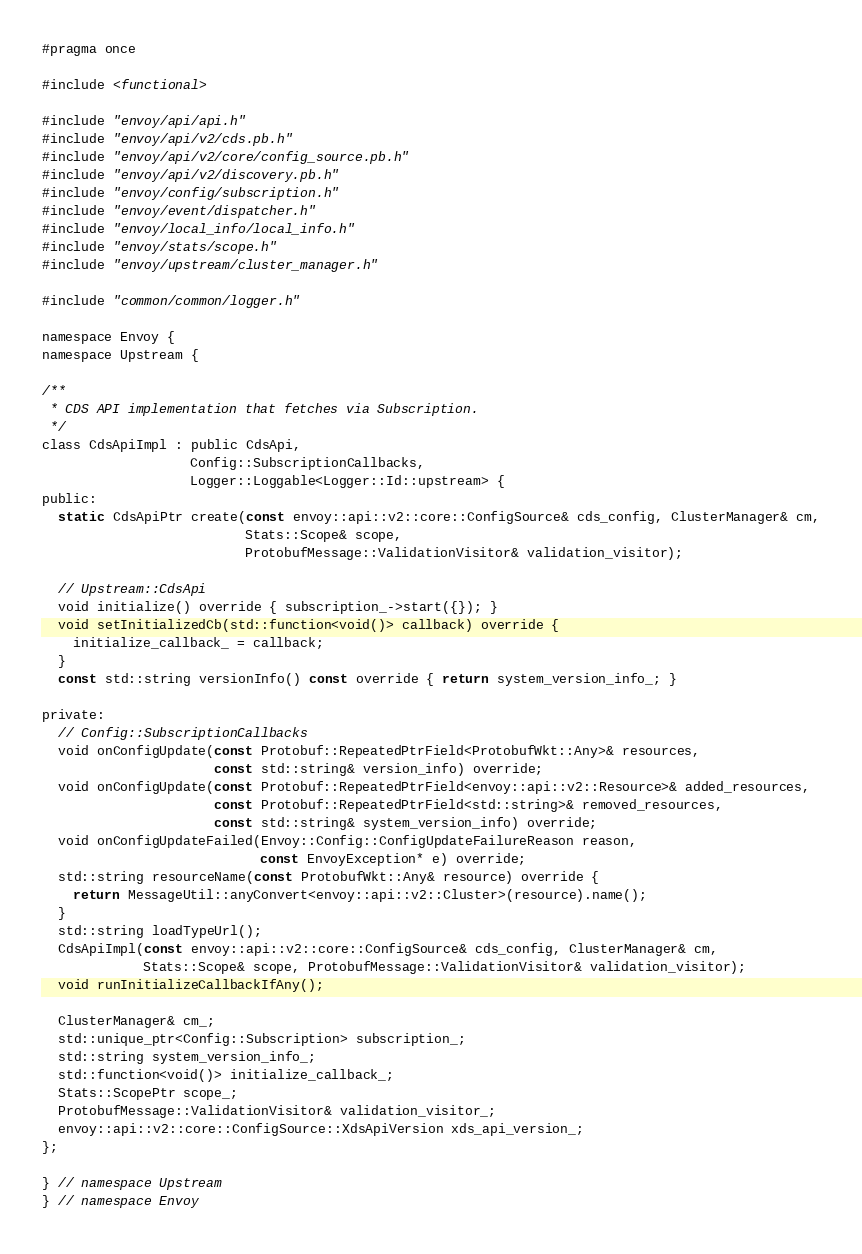Convert code to text. <code><loc_0><loc_0><loc_500><loc_500><_C_>#pragma once

#include <functional>

#include "envoy/api/api.h"
#include "envoy/api/v2/cds.pb.h"
#include "envoy/api/v2/core/config_source.pb.h"
#include "envoy/api/v2/discovery.pb.h"
#include "envoy/config/subscription.h"
#include "envoy/event/dispatcher.h"
#include "envoy/local_info/local_info.h"
#include "envoy/stats/scope.h"
#include "envoy/upstream/cluster_manager.h"

#include "common/common/logger.h"

namespace Envoy {
namespace Upstream {

/**
 * CDS API implementation that fetches via Subscription.
 */
class CdsApiImpl : public CdsApi,
                   Config::SubscriptionCallbacks,
                   Logger::Loggable<Logger::Id::upstream> {
public:
  static CdsApiPtr create(const envoy::api::v2::core::ConfigSource& cds_config, ClusterManager& cm,
                          Stats::Scope& scope,
                          ProtobufMessage::ValidationVisitor& validation_visitor);

  // Upstream::CdsApi
  void initialize() override { subscription_->start({}); }
  void setInitializedCb(std::function<void()> callback) override {
    initialize_callback_ = callback;
  }
  const std::string versionInfo() const override { return system_version_info_; }

private:
  // Config::SubscriptionCallbacks
  void onConfigUpdate(const Protobuf::RepeatedPtrField<ProtobufWkt::Any>& resources,
                      const std::string& version_info) override;
  void onConfigUpdate(const Protobuf::RepeatedPtrField<envoy::api::v2::Resource>& added_resources,
                      const Protobuf::RepeatedPtrField<std::string>& removed_resources,
                      const std::string& system_version_info) override;
  void onConfigUpdateFailed(Envoy::Config::ConfigUpdateFailureReason reason,
                            const EnvoyException* e) override;
  std::string resourceName(const ProtobufWkt::Any& resource) override {
    return MessageUtil::anyConvert<envoy::api::v2::Cluster>(resource).name();
  }
  std::string loadTypeUrl();
  CdsApiImpl(const envoy::api::v2::core::ConfigSource& cds_config, ClusterManager& cm,
             Stats::Scope& scope, ProtobufMessage::ValidationVisitor& validation_visitor);
  void runInitializeCallbackIfAny();

  ClusterManager& cm_;
  std::unique_ptr<Config::Subscription> subscription_;
  std::string system_version_info_;
  std::function<void()> initialize_callback_;
  Stats::ScopePtr scope_;
  ProtobufMessage::ValidationVisitor& validation_visitor_;
  envoy::api::v2::core::ConfigSource::XdsApiVersion xds_api_version_;
};

} // namespace Upstream
} // namespace Envoy
</code> 